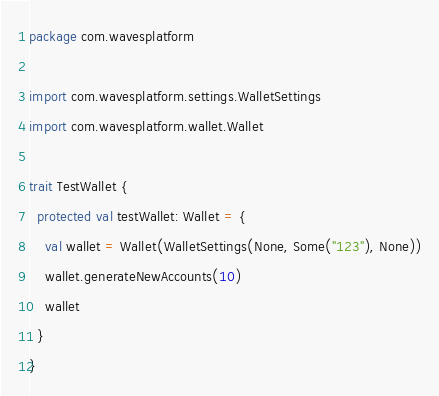Convert code to text. <code><loc_0><loc_0><loc_500><loc_500><_Scala_>package com.wavesplatform

import com.wavesplatform.settings.WalletSettings
import com.wavesplatform.wallet.Wallet

trait TestWallet {
  protected val testWallet: Wallet = {
    val wallet = Wallet(WalletSettings(None, Some("123"), None))
    wallet.generateNewAccounts(10)
    wallet
  }
}
</code> 